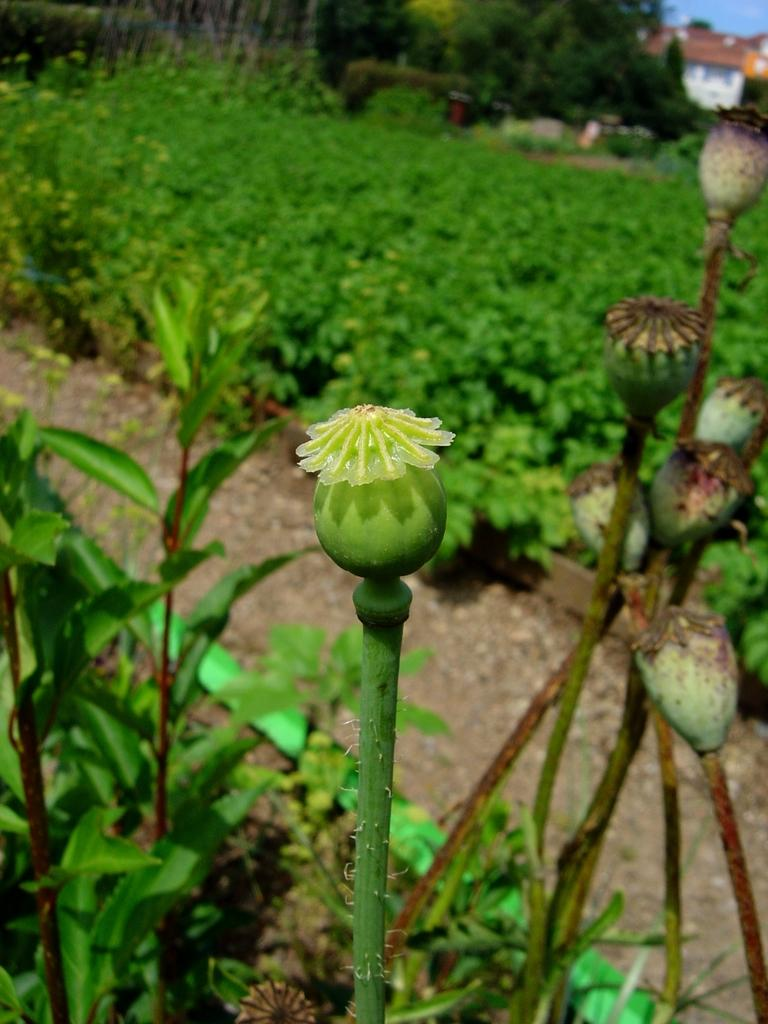What type of vegetation can be seen in the image? There are many trees and plants in the image. What type of structure is present in the image? There is a house in the image. What color is the sky in the image? The sky is blue in the image. What additional features can be seen on the plants? There are flowers on the plants. Can you see a watch on any of the trees in the image? There is no watch present on any of the trees in the image. Is there anyone kicking a soccer ball in the image? There is no soccer ball or person kicking it in the image. 